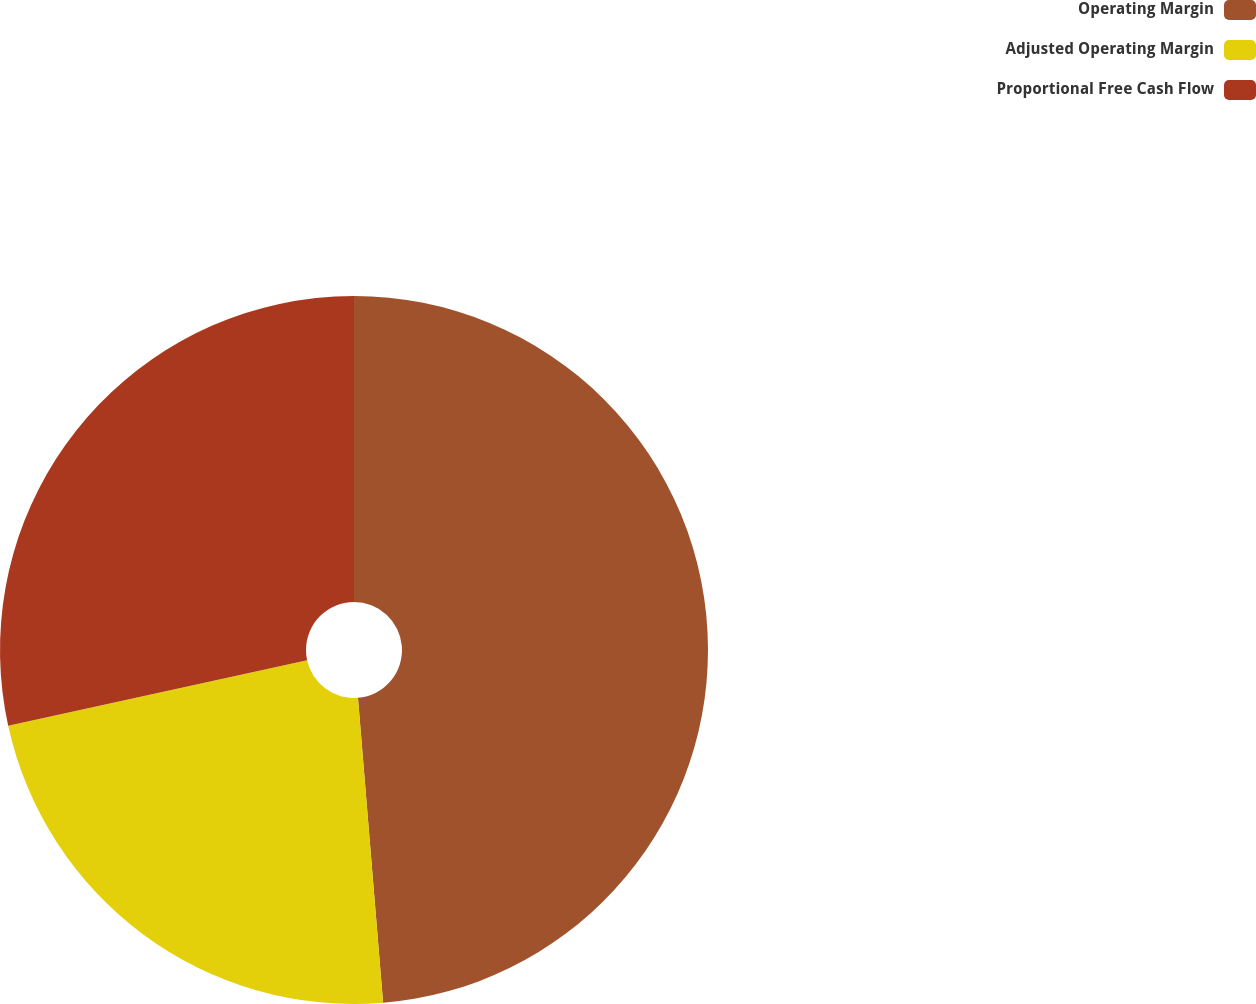Convert chart. <chart><loc_0><loc_0><loc_500><loc_500><pie_chart><fcel>Operating Margin<fcel>Adjusted Operating Margin<fcel>Proportional Free Cash Flow<nl><fcel>48.69%<fcel>22.88%<fcel>28.43%<nl></chart> 